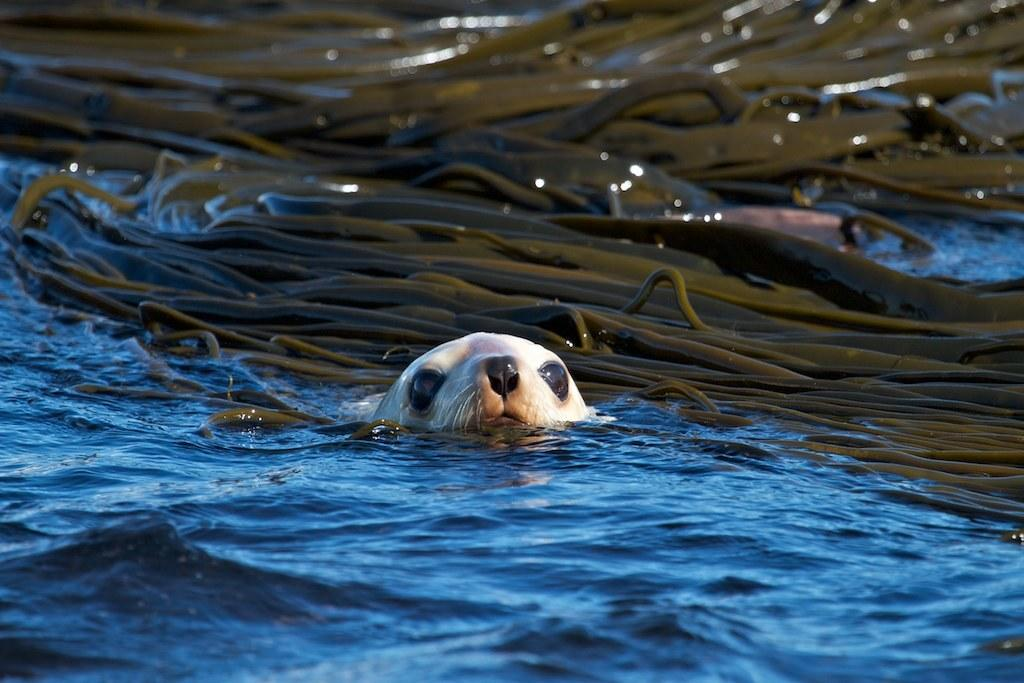What is the primary element present in the image? There is water in the image. What types of creatures can be seen in the water? There are many animals in the water. What type of chalk can be seen being used by the animals in the image? There is no chalk present in the image, and the animals are not using any chalk. 